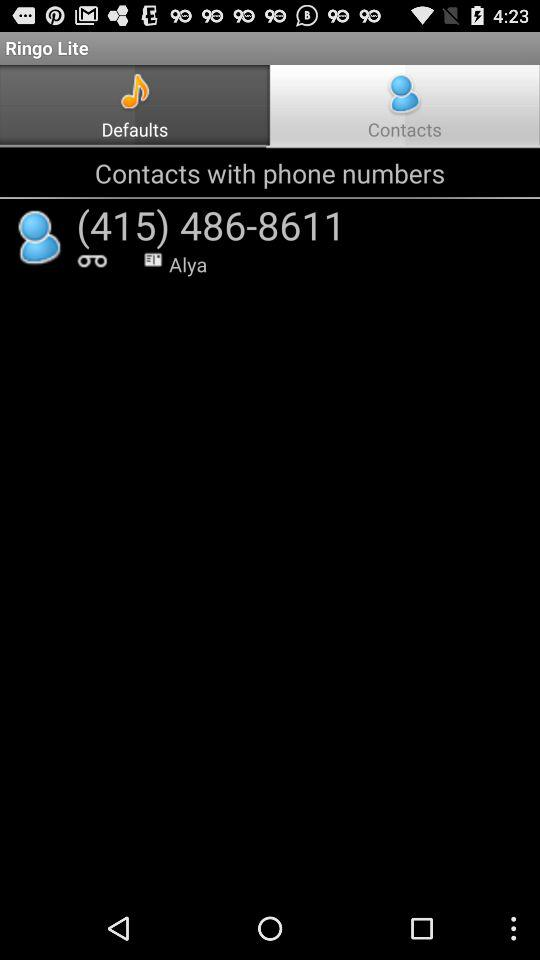Which tab is selected? The selected tab is "Contacts". 